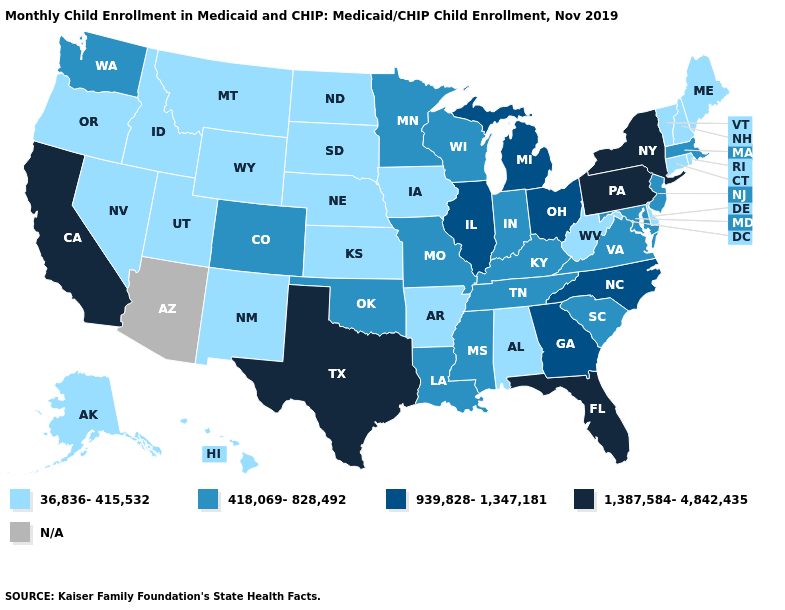Name the states that have a value in the range N/A?
Quick response, please. Arizona. Name the states that have a value in the range 36,836-415,532?
Answer briefly. Alabama, Alaska, Arkansas, Connecticut, Delaware, Hawaii, Idaho, Iowa, Kansas, Maine, Montana, Nebraska, Nevada, New Hampshire, New Mexico, North Dakota, Oregon, Rhode Island, South Dakota, Utah, Vermont, West Virginia, Wyoming. What is the value of Kentucky?
Keep it brief. 418,069-828,492. Does North Dakota have the lowest value in the USA?
Short answer required. Yes. What is the value of South Carolina?
Quick response, please. 418,069-828,492. Which states have the lowest value in the USA?
Write a very short answer. Alabama, Alaska, Arkansas, Connecticut, Delaware, Hawaii, Idaho, Iowa, Kansas, Maine, Montana, Nebraska, Nevada, New Hampshire, New Mexico, North Dakota, Oregon, Rhode Island, South Dakota, Utah, Vermont, West Virginia, Wyoming. Is the legend a continuous bar?
Keep it brief. No. Name the states that have a value in the range 418,069-828,492?
Answer briefly. Colorado, Indiana, Kentucky, Louisiana, Maryland, Massachusetts, Minnesota, Mississippi, Missouri, New Jersey, Oklahoma, South Carolina, Tennessee, Virginia, Washington, Wisconsin. Is the legend a continuous bar?
Write a very short answer. No. Which states have the highest value in the USA?
Keep it brief. California, Florida, New York, Pennsylvania, Texas. What is the value of Nebraska?
Short answer required. 36,836-415,532. Name the states that have a value in the range 1,387,584-4,842,435?
Keep it brief. California, Florida, New York, Pennsylvania, Texas. What is the highest value in states that border South Carolina?
Concise answer only. 939,828-1,347,181. 